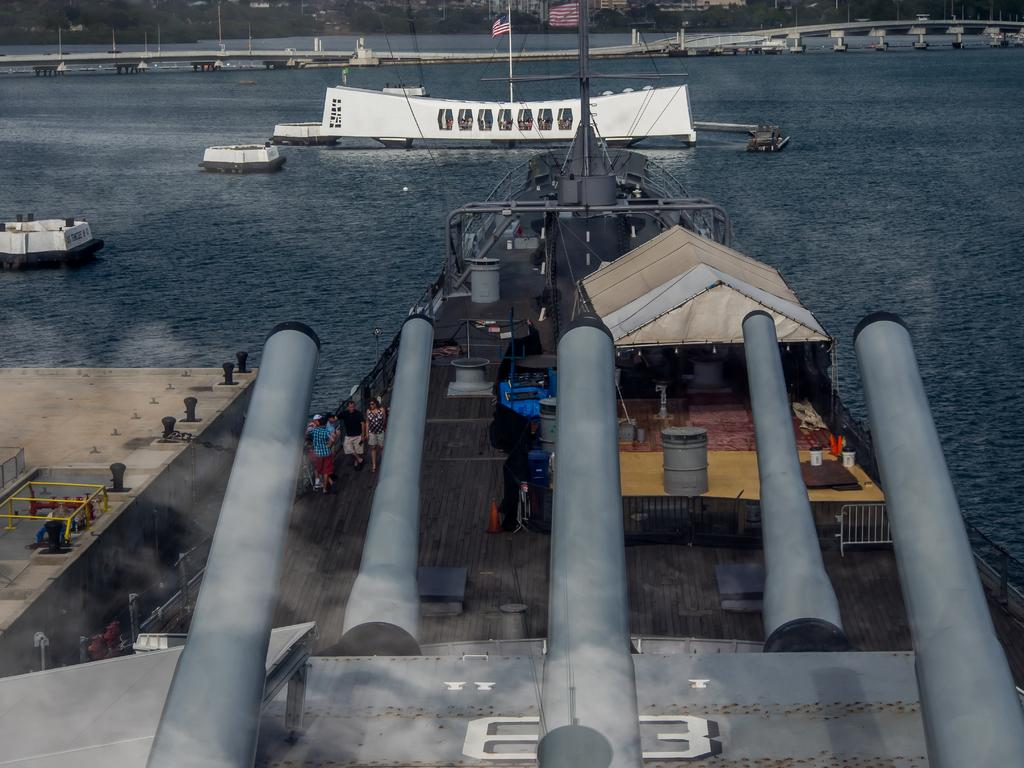How many people are in the image? There is a group of people in the image, but the exact number cannot be determined from the provided facts. Where are the people located in the image? The people are standing on a ship in the image. What can be seen in the background of the image? In the background of the image, there is a bridge, flags, a group of poles, and a shed. What type of mint is growing on the street in the image? There is no mint or street present in the image; it features a group of people on a ship with a background containing a bridge, flags, poles, and a shed. Can you tell me how many balls are visible in the image? There are no balls present in the image. 